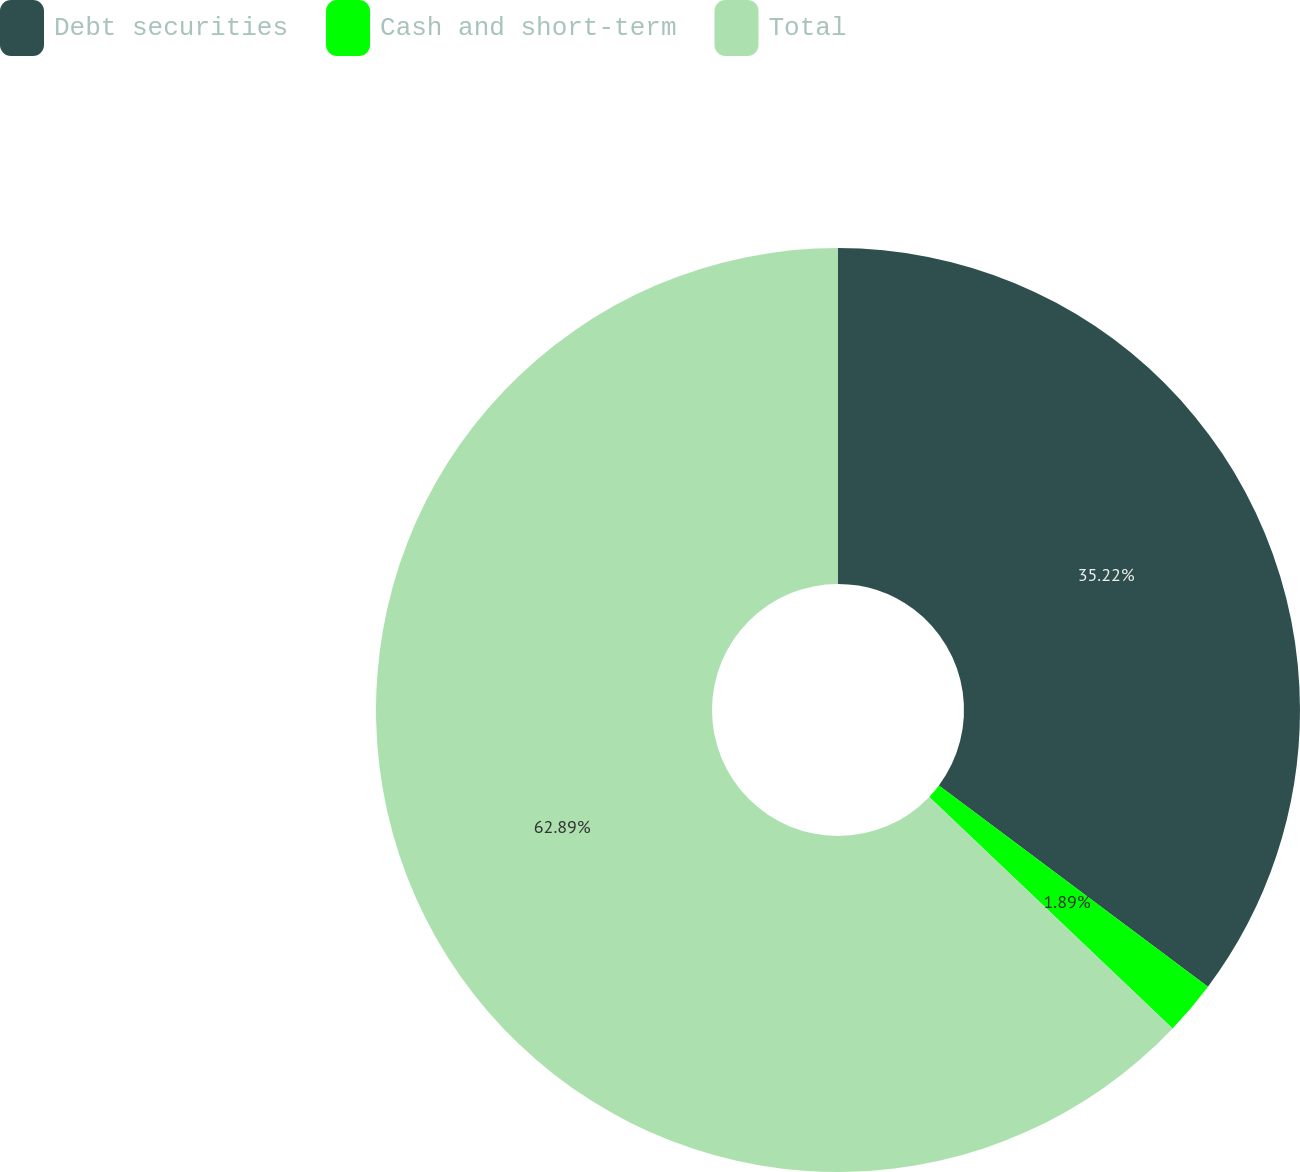Convert chart to OTSL. <chart><loc_0><loc_0><loc_500><loc_500><pie_chart><fcel>Debt securities<fcel>Cash and short-term<fcel>Total<nl><fcel>35.22%<fcel>1.89%<fcel>62.89%<nl></chart> 